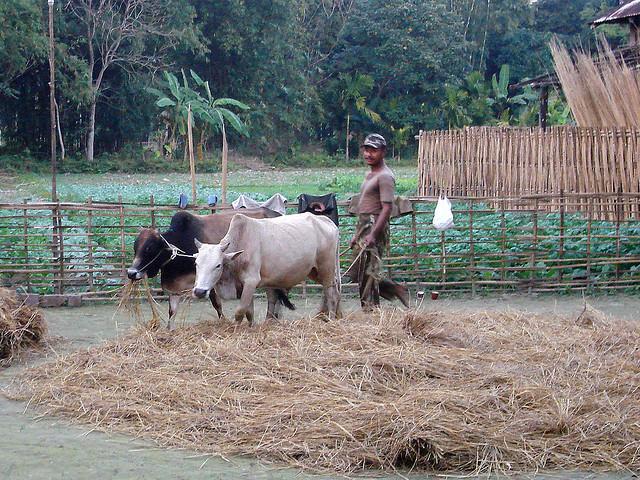Are children playing beyond the fence?
Quick response, please. No. What type of climate is this?
Be succinct. Tropical. What is the man doing with the stick?
Answer briefly. Herding. Are the animals heifers or bulls?
Write a very short answer. Bulls. 